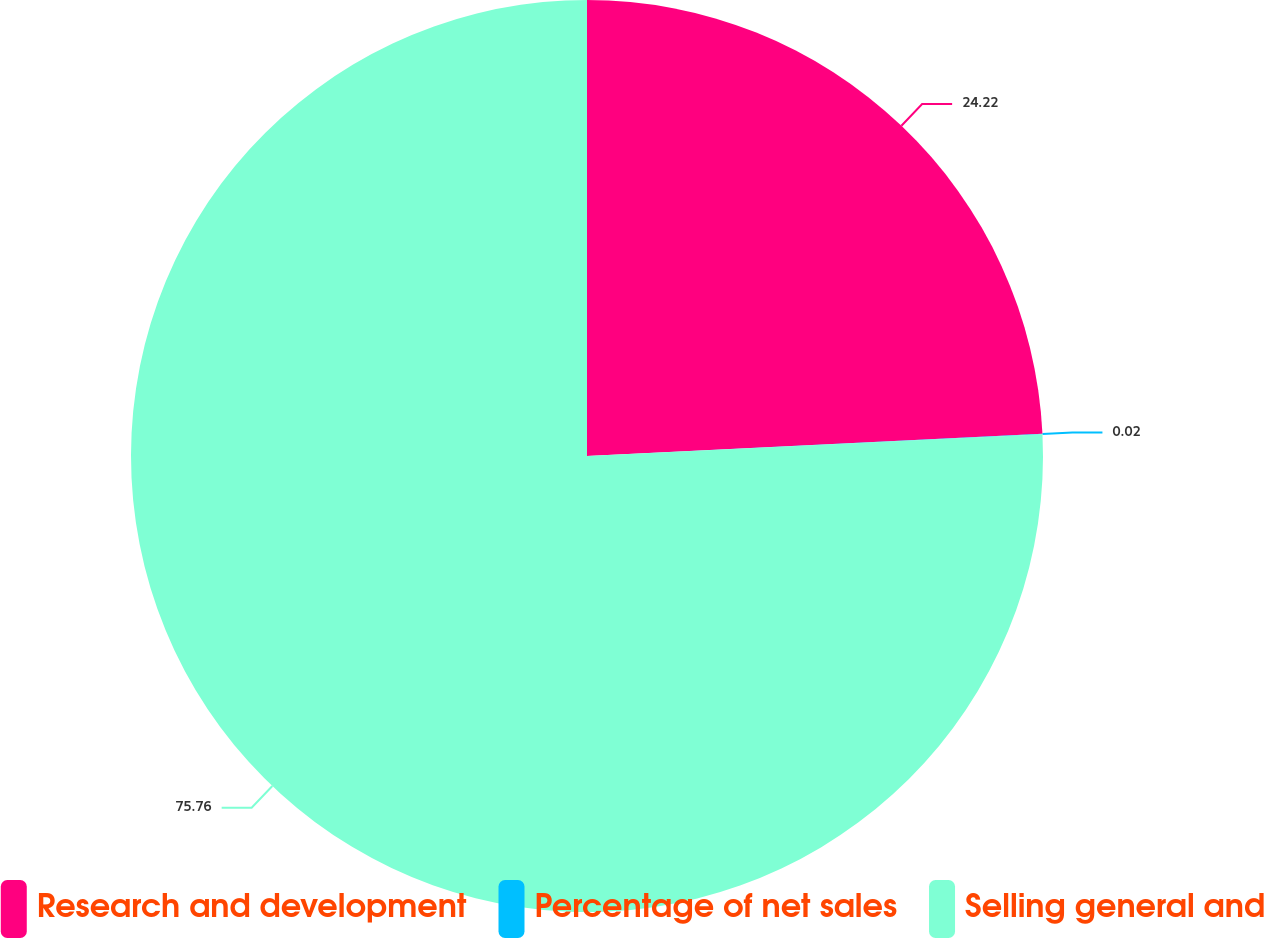Convert chart to OTSL. <chart><loc_0><loc_0><loc_500><loc_500><pie_chart><fcel>Research and development<fcel>Percentage of net sales<fcel>Selling general and<nl><fcel>24.22%<fcel>0.02%<fcel>75.76%<nl></chart> 